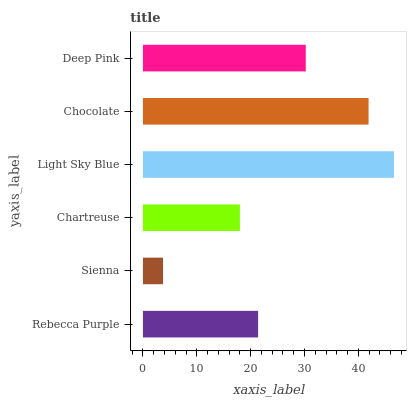Is Sienna the minimum?
Answer yes or no. Yes. Is Light Sky Blue the maximum?
Answer yes or no. Yes. Is Chartreuse the minimum?
Answer yes or no. No. Is Chartreuse the maximum?
Answer yes or no. No. Is Chartreuse greater than Sienna?
Answer yes or no. Yes. Is Sienna less than Chartreuse?
Answer yes or no. Yes. Is Sienna greater than Chartreuse?
Answer yes or no. No. Is Chartreuse less than Sienna?
Answer yes or no. No. Is Deep Pink the high median?
Answer yes or no. Yes. Is Rebecca Purple the low median?
Answer yes or no. Yes. Is Rebecca Purple the high median?
Answer yes or no. No. Is Chartreuse the low median?
Answer yes or no. No. 